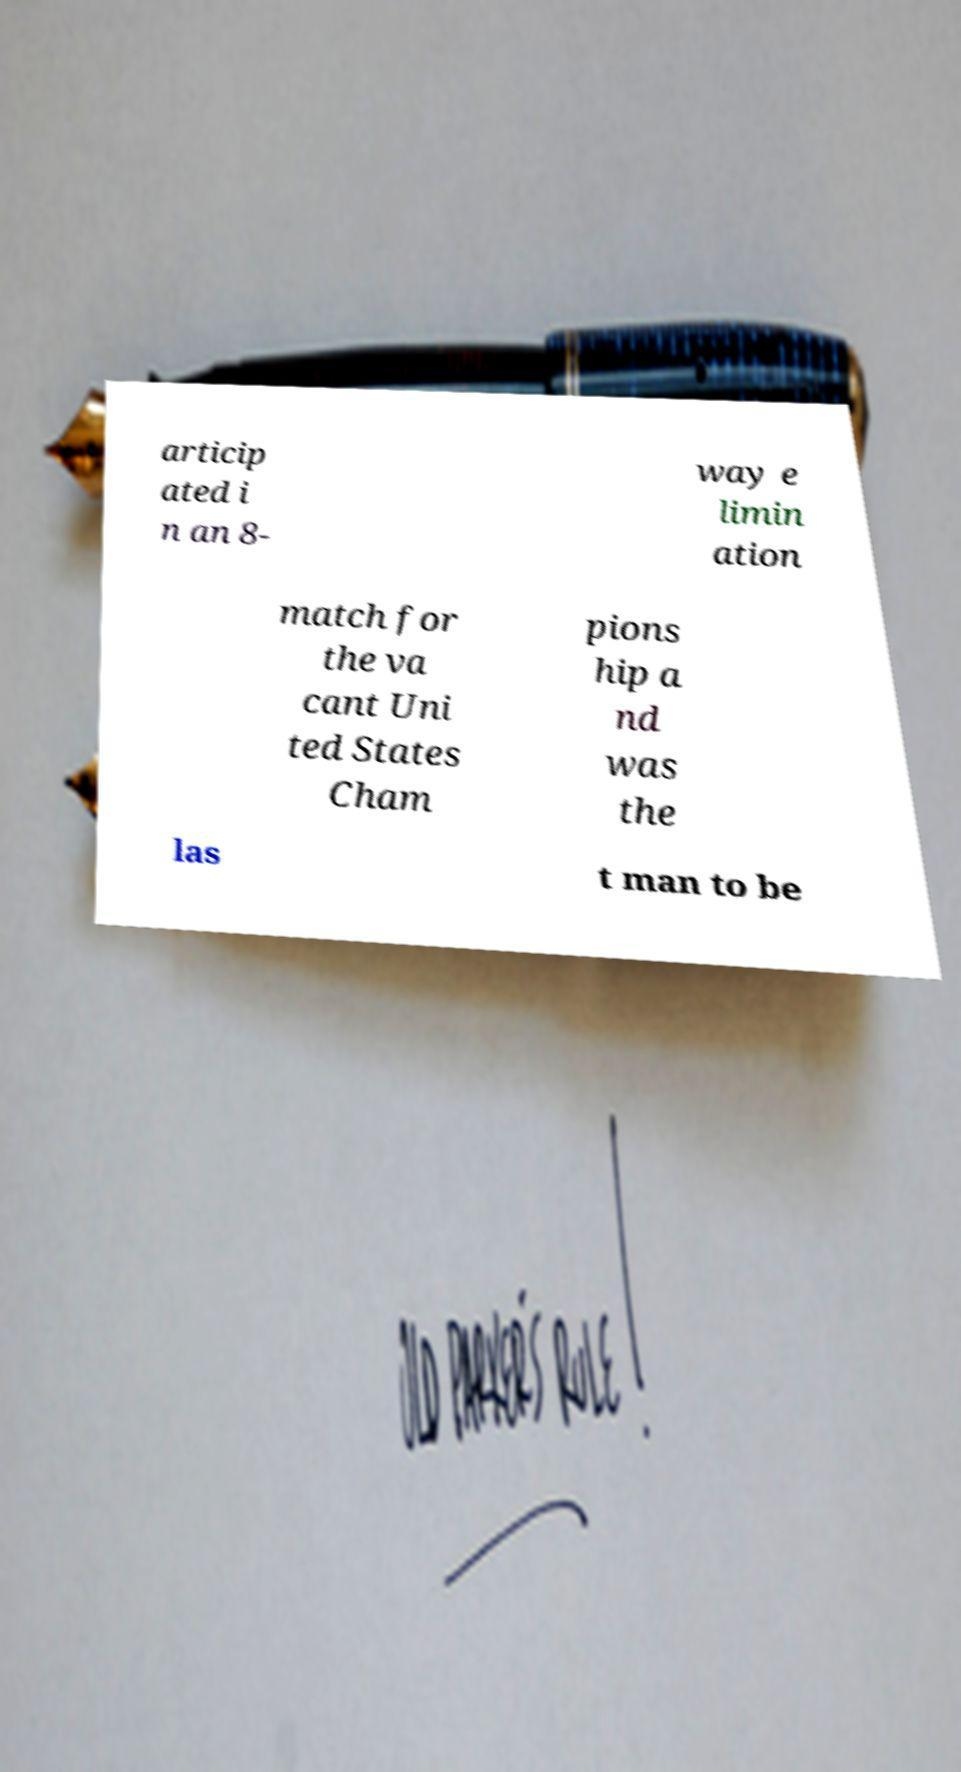Please read and relay the text visible in this image. What does it say? articip ated i n an 8- way e limin ation match for the va cant Uni ted States Cham pions hip a nd was the las t man to be 